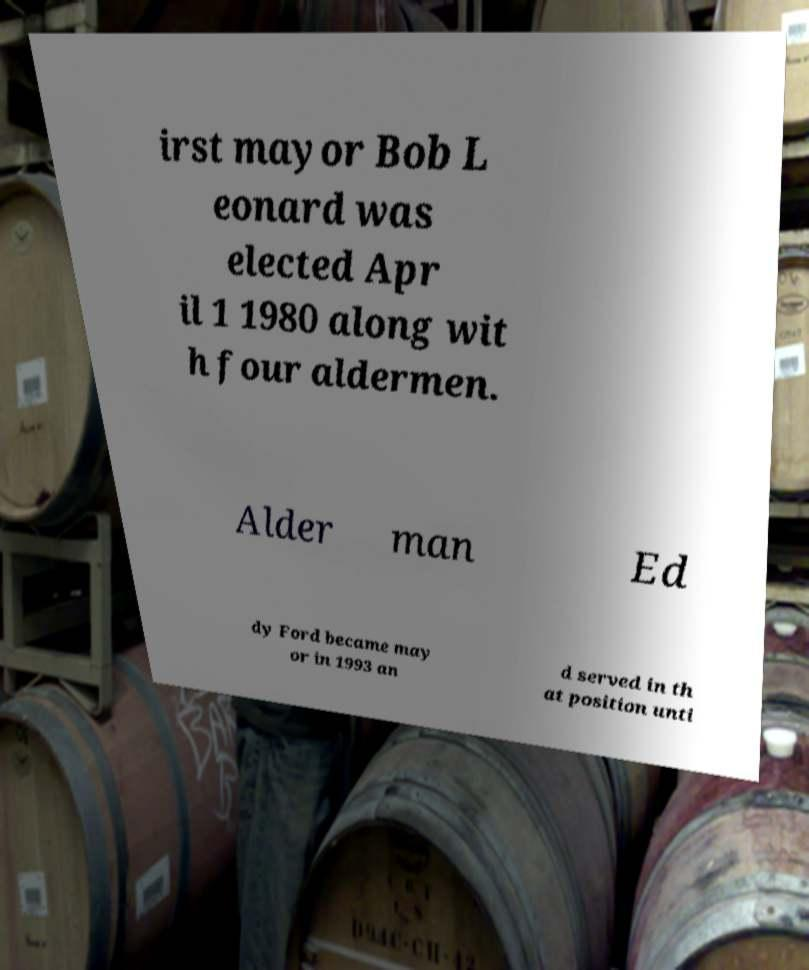What messages or text are displayed in this image? I need them in a readable, typed format. irst mayor Bob L eonard was elected Apr il 1 1980 along wit h four aldermen. Alder man Ed dy Ford became may or in 1993 an d served in th at position unti 